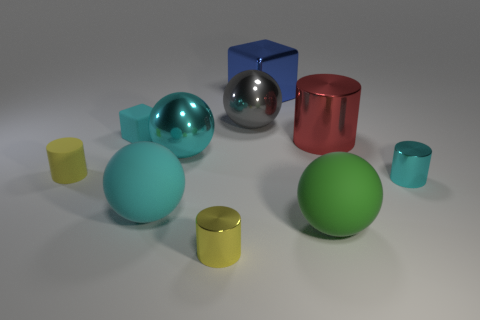Is there a large red cylinder that is in front of the tiny metal thing to the left of the large blue block?
Ensure brevity in your answer.  No. Does the cylinder that is behind the yellow rubber object have the same size as the cyan block?
Give a very brief answer. No. How big is the red shiny cylinder?
Provide a succinct answer. Large. Are there any tiny matte spheres of the same color as the matte cylinder?
Ensure brevity in your answer.  No. How many big things are rubber blocks or gray metal objects?
Offer a terse response. 1. What size is the cylinder that is on the left side of the gray ball and right of the cyan cube?
Keep it short and to the point. Small. There is a green thing; what number of red cylinders are left of it?
Your answer should be very brief. 0. What shape is the large thing that is on the right side of the big gray metallic thing and in front of the yellow matte object?
Your response must be concise. Sphere. There is a cylinder that is the same color as the rubber cube; what is it made of?
Make the answer very short. Metal. What number of spheres are large shiny objects or metal objects?
Your response must be concise. 2. 